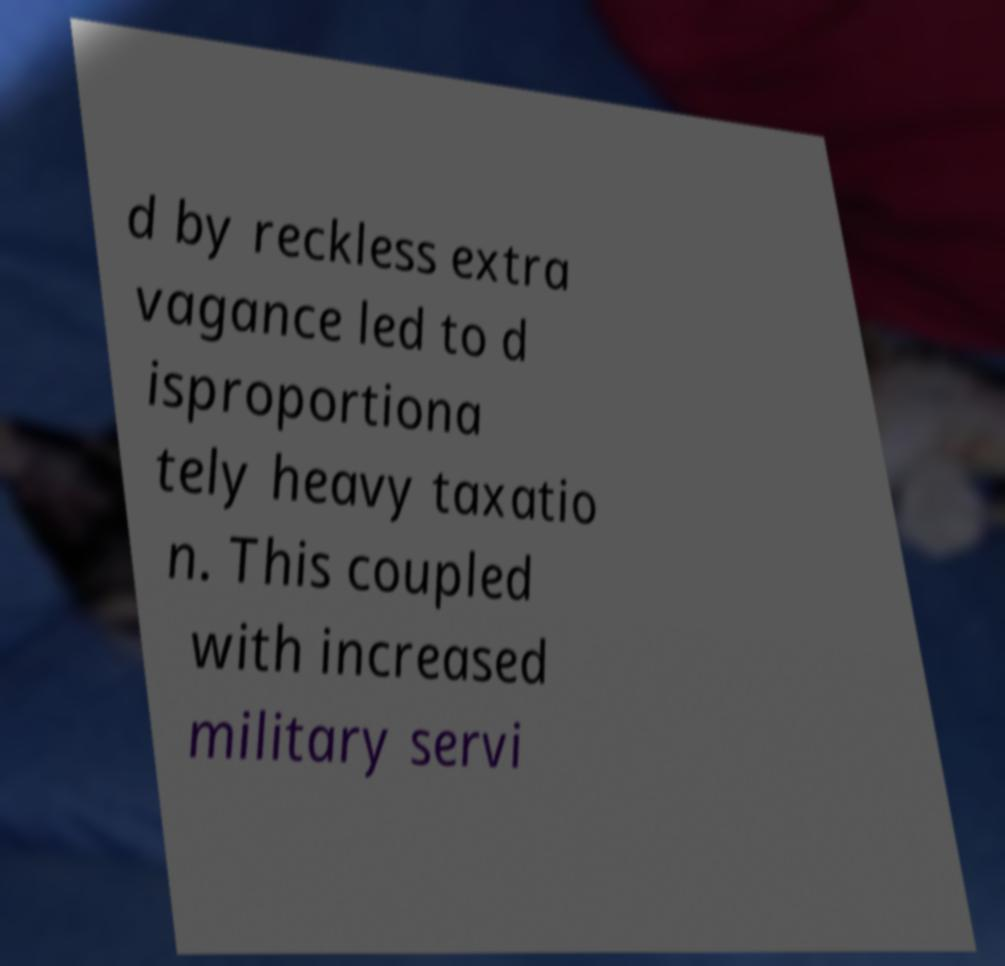Could you extract and type out the text from this image? d by reckless extra vagance led to d isproportiona tely heavy taxatio n. This coupled with increased military servi 